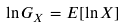<formula> <loc_0><loc_0><loc_500><loc_500>\ln G _ { X } = E [ \ln X ]</formula> 